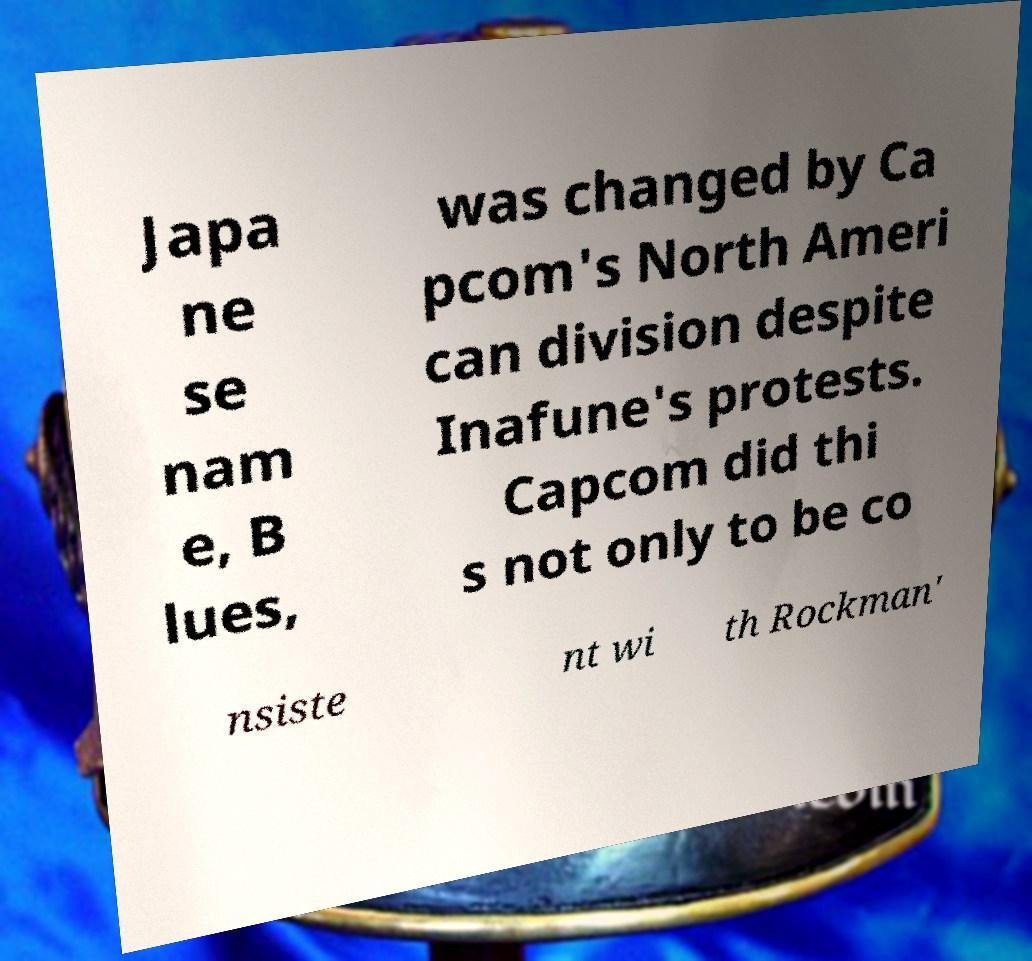Can you accurately transcribe the text from the provided image for me? Japa ne se nam e, B lues, was changed by Ca pcom's North Ameri can division despite Inafune's protests. Capcom did thi s not only to be co nsiste nt wi th Rockman' 